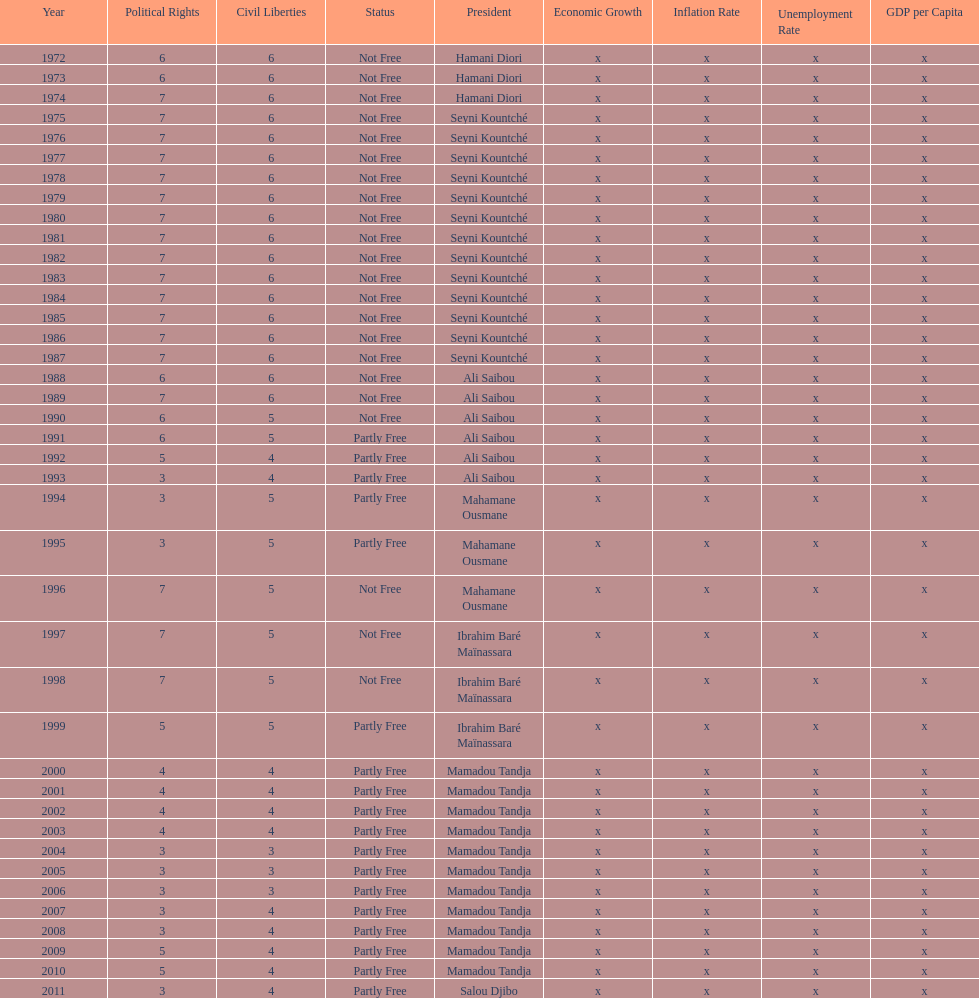How many years was it before the first partly free status? 18. 